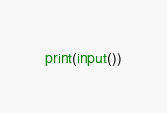<code> <loc_0><loc_0><loc_500><loc_500><_Python_>print(input())</code> 